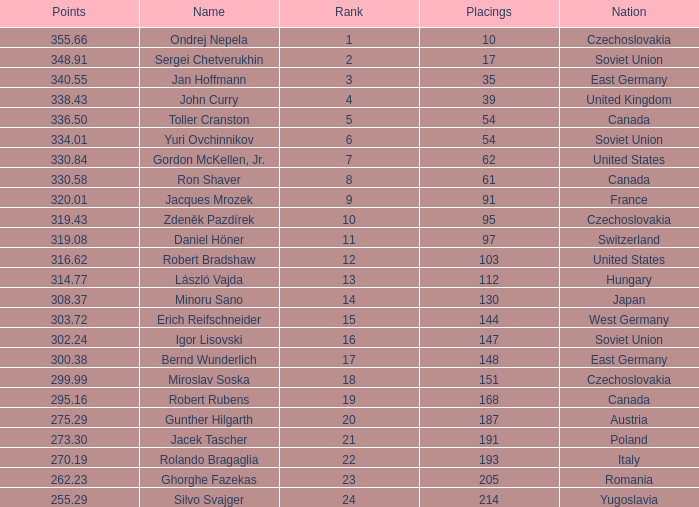How many Placings have Points smaller than 330.84, and a Name of silvo svajger? 1.0. Give me the full table as a dictionary. {'header': ['Points', 'Name', 'Rank', 'Placings', 'Nation'], 'rows': [['355.66', 'Ondrej Nepela', '1', '10', 'Czechoslovakia'], ['348.91', 'Sergei Chetverukhin', '2', '17', 'Soviet Union'], ['340.55', 'Jan Hoffmann', '3', '35', 'East Germany'], ['338.43', 'John Curry', '4', '39', 'United Kingdom'], ['336.50', 'Toller Cranston', '5', '54', 'Canada'], ['334.01', 'Yuri Ovchinnikov', '6', '54', 'Soviet Union'], ['330.84', 'Gordon McKellen, Jr.', '7', '62', 'United States'], ['330.58', 'Ron Shaver', '8', '61', 'Canada'], ['320.01', 'Jacques Mrozek', '9', '91', 'France'], ['319.43', 'Zdeněk Pazdírek', '10', '95', 'Czechoslovakia'], ['319.08', 'Daniel Höner', '11', '97', 'Switzerland'], ['316.62', 'Robert Bradshaw', '12', '103', 'United States'], ['314.77', 'László Vajda', '13', '112', 'Hungary'], ['308.37', 'Minoru Sano', '14', '130', 'Japan'], ['303.72', 'Erich Reifschneider', '15', '144', 'West Germany'], ['302.24', 'Igor Lisovski', '16', '147', 'Soviet Union'], ['300.38', 'Bernd Wunderlich', '17', '148', 'East Germany'], ['299.99', 'Miroslav Soska', '18', '151', 'Czechoslovakia'], ['295.16', 'Robert Rubens', '19', '168', 'Canada'], ['275.29', 'Gunther Hilgarth', '20', '187', 'Austria'], ['273.30', 'Jacek Tascher', '21', '191', 'Poland'], ['270.19', 'Rolando Bragaglia', '22', '193', 'Italy'], ['262.23', 'Ghorghe Fazekas', '23', '205', 'Romania'], ['255.29', 'Silvo Svajger', '24', '214', 'Yugoslavia']]} 